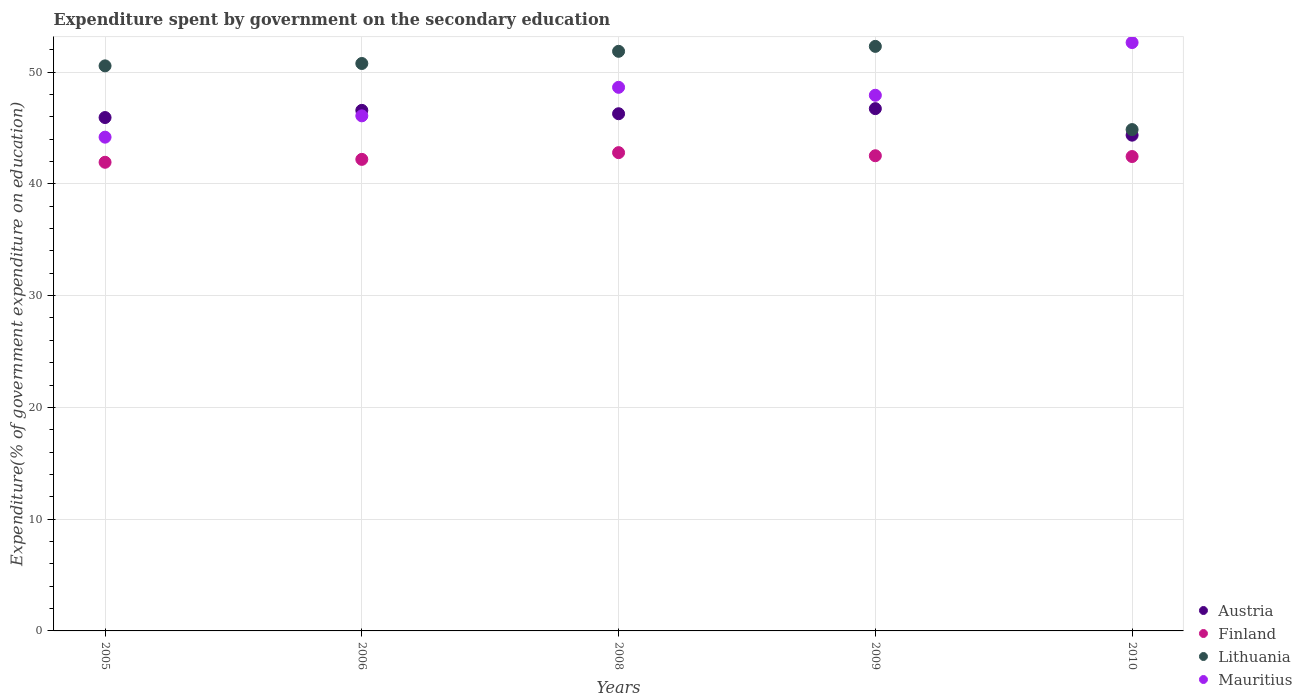What is the expenditure spent by government on the secondary education in Austria in 2005?
Your answer should be very brief. 45.94. Across all years, what is the maximum expenditure spent by government on the secondary education in Lithuania?
Keep it short and to the point. 52.3. Across all years, what is the minimum expenditure spent by government on the secondary education in Mauritius?
Ensure brevity in your answer.  44.18. In which year was the expenditure spent by government on the secondary education in Mauritius minimum?
Provide a succinct answer. 2005. What is the total expenditure spent by government on the secondary education in Mauritius in the graph?
Provide a succinct answer. 239.49. What is the difference between the expenditure spent by government on the secondary education in Finland in 2005 and that in 2006?
Provide a succinct answer. -0.26. What is the difference between the expenditure spent by government on the secondary education in Finland in 2006 and the expenditure spent by government on the secondary education in Austria in 2005?
Your answer should be compact. -3.74. What is the average expenditure spent by government on the secondary education in Finland per year?
Keep it short and to the point. 42.38. In the year 2008, what is the difference between the expenditure spent by government on the secondary education in Mauritius and expenditure spent by government on the secondary education in Lithuania?
Provide a succinct answer. -3.22. What is the ratio of the expenditure spent by government on the secondary education in Lithuania in 2008 to that in 2010?
Offer a very short reply. 1.16. What is the difference between the highest and the second highest expenditure spent by government on the secondary education in Lithuania?
Your response must be concise. 0.44. What is the difference between the highest and the lowest expenditure spent by government on the secondary education in Finland?
Make the answer very short. 0.86. Is it the case that in every year, the sum of the expenditure spent by government on the secondary education in Finland and expenditure spent by government on the secondary education in Mauritius  is greater than the sum of expenditure spent by government on the secondary education in Lithuania and expenditure spent by government on the secondary education in Austria?
Keep it short and to the point. No. Does the expenditure spent by government on the secondary education in Finland monotonically increase over the years?
Your answer should be very brief. No. How many years are there in the graph?
Your answer should be very brief. 5. Are the values on the major ticks of Y-axis written in scientific E-notation?
Your answer should be very brief. No. Where does the legend appear in the graph?
Your response must be concise. Bottom right. What is the title of the graph?
Make the answer very short. Expenditure spent by government on the secondary education. What is the label or title of the Y-axis?
Offer a terse response. Expenditure(% of government expenditure on education). What is the Expenditure(% of government expenditure on education) in Austria in 2005?
Give a very brief answer. 45.94. What is the Expenditure(% of government expenditure on education) in Finland in 2005?
Provide a short and direct response. 41.93. What is the Expenditure(% of government expenditure on education) of Lithuania in 2005?
Provide a succinct answer. 50.56. What is the Expenditure(% of government expenditure on education) of Mauritius in 2005?
Offer a terse response. 44.18. What is the Expenditure(% of government expenditure on education) of Austria in 2006?
Provide a succinct answer. 46.58. What is the Expenditure(% of government expenditure on education) of Finland in 2006?
Provide a short and direct response. 42.19. What is the Expenditure(% of government expenditure on education) of Lithuania in 2006?
Ensure brevity in your answer.  50.77. What is the Expenditure(% of government expenditure on education) in Mauritius in 2006?
Your answer should be very brief. 46.09. What is the Expenditure(% of government expenditure on education) of Austria in 2008?
Offer a very short reply. 46.28. What is the Expenditure(% of government expenditure on education) in Finland in 2008?
Provide a succinct answer. 42.8. What is the Expenditure(% of government expenditure on education) in Lithuania in 2008?
Your response must be concise. 51.86. What is the Expenditure(% of government expenditure on education) in Mauritius in 2008?
Provide a short and direct response. 48.64. What is the Expenditure(% of government expenditure on education) of Austria in 2009?
Make the answer very short. 46.73. What is the Expenditure(% of government expenditure on education) of Finland in 2009?
Offer a very short reply. 42.52. What is the Expenditure(% of government expenditure on education) in Lithuania in 2009?
Ensure brevity in your answer.  52.3. What is the Expenditure(% of government expenditure on education) in Mauritius in 2009?
Make the answer very short. 47.93. What is the Expenditure(% of government expenditure on education) of Austria in 2010?
Your answer should be compact. 44.36. What is the Expenditure(% of government expenditure on education) in Finland in 2010?
Your answer should be very brief. 42.45. What is the Expenditure(% of government expenditure on education) of Lithuania in 2010?
Give a very brief answer. 44.86. What is the Expenditure(% of government expenditure on education) of Mauritius in 2010?
Give a very brief answer. 52.65. Across all years, what is the maximum Expenditure(% of government expenditure on education) of Austria?
Provide a succinct answer. 46.73. Across all years, what is the maximum Expenditure(% of government expenditure on education) of Finland?
Your answer should be very brief. 42.8. Across all years, what is the maximum Expenditure(% of government expenditure on education) of Lithuania?
Your answer should be very brief. 52.3. Across all years, what is the maximum Expenditure(% of government expenditure on education) in Mauritius?
Provide a succinct answer. 52.65. Across all years, what is the minimum Expenditure(% of government expenditure on education) in Austria?
Offer a terse response. 44.36. Across all years, what is the minimum Expenditure(% of government expenditure on education) in Finland?
Your answer should be very brief. 41.93. Across all years, what is the minimum Expenditure(% of government expenditure on education) of Lithuania?
Provide a succinct answer. 44.86. Across all years, what is the minimum Expenditure(% of government expenditure on education) of Mauritius?
Offer a terse response. 44.18. What is the total Expenditure(% of government expenditure on education) in Austria in the graph?
Offer a very short reply. 229.89. What is the total Expenditure(% of government expenditure on education) of Finland in the graph?
Ensure brevity in your answer.  211.89. What is the total Expenditure(% of government expenditure on education) in Lithuania in the graph?
Provide a succinct answer. 250.36. What is the total Expenditure(% of government expenditure on education) in Mauritius in the graph?
Your response must be concise. 239.49. What is the difference between the Expenditure(% of government expenditure on education) in Austria in 2005 and that in 2006?
Offer a terse response. -0.64. What is the difference between the Expenditure(% of government expenditure on education) of Finland in 2005 and that in 2006?
Give a very brief answer. -0.26. What is the difference between the Expenditure(% of government expenditure on education) of Lithuania in 2005 and that in 2006?
Give a very brief answer. -0.21. What is the difference between the Expenditure(% of government expenditure on education) in Mauritius in 2005 and that in 2006?
Provide a succinct answer. -1.91. What is the difference between the Expenditure(% of government expenditure on education) in Austria in 2005 and that in 2008?
Your response must be concise. -0.34. What is the difference between the Expenditure(% of government expenditure on education) of Finland in 2005 and that in 2008?
Your answer should be very brief. -0.86. What is the difference between the Expenditure(% of government expenditure on education) of Lithuania in 2005 and that in 2008?
Keep it short and to the point. -1.3. What is the difference between the Expenditure(% of government expenditure on education) of Mauritius in 2005 and that in 2008?
Provide a succinct answer. -4.46. What is the difference between the Expenditure(% of government expenditure on education) in Austria in 2005 and that in 2009?
Provide a succinct answer. -0.8. What is the difference between the Expenditure(% of government expenditure on education) in Finland in 2005 and that in 2009?
Make the answer very short. -0.58. What is the difference between the Expenditure(% of government expenditure on education) of Lithuania in 2005 and that in 2009?
Provide a short and direct response. -1.74. What is the difference between the Expenditure(% of government expenditure on education) in Mauritius in 2005 and that in 2009?
Offer a terse response. -3.75. What is the difference between the Expenditure(% of government expenditure on education) of Austria in 2005 and that in 2010?
Your response must be concise. 1.58. What is the difference between the Expenditure(% of government expenditure on education) of Finland in 2005 and that in 2010?
Give a very brief answer. -0.51. What is the difference between the Expenditure(% of government expenditure on education) of Lithuania in 2005 and that in 2010?
Offer a terse response. 5.7. What is the difference between the Expenditure(% of government expenditure on education) of Mauritius in 2005 and that in 2010?
Ensure brevity in your answer.  -8.46. What is the difference between the Expenditure(% of government expenditure on education) of Austria in 2006 and that in 2008?
Give a very brief answer. 0.3. What is the difference between the Expenditure(% of government expenditure on education) in Finland in 2006 and that in 2008?
Make the answer very short. -0.6. What is the difference between the Expenditure(% of government expenditure on education) in Lithuania in 2006 and that in 2008?
Keep it short and to the point. -1.09. What is the difference between the Expenditure(% of government expenditure on education) of Mauritius in 2006 and that in 2008?
Give a very brief answer. -2.55. What is the difference between the Expenditure(% of government expenditure on education) of Austria in 2006 and that in 2009?
Provide a succinct answer. -0.15. What is the difference between the Expenditure(% of government expenditure on education) in Finland in 2006 and that in 2009?
Your response must be concise. -0.32. What is the difference between the Expenditure(% of government expenditure on education) in Lithuania in 2006 and that in 2009?
Keep it short and to the point. -1.53. What is the difference between the Expenditure(% of government expenditure on education) of Mauritius in 2006 and that in 2009?
Provide a succinct answer. -1.84. What is the difference between the Expenditure(% of government expenditure on education) in Austria in 2006 and that in 2010?
Your response must be concise. 2.22. What is the difference between the Expenditure(% of government expenditure on education) of Finland in 2006 and that in 2010?
Ensure brevity in your answer.  -0.25. What is the difference between the Expenditure(% of government expenditure on education) of Lithuania in 2006 and that in 2010?
Your response must be concise. 5.91. What is the difference between the Expenditure(% of government expenditure on education) of Mauritius in 2006 and that in 2010?
Keep it short and to the point. -6.56. What is the difference between the Expenditure(% of government expenditure on education) in Austria in 2008 and that in 2009?
Offer a very short reply. -0.46. What is the difference between the Expenditure(% of government expenditure on education) of Finland in 2008 and that in 2009?
Provide a succinct answer. 0.28. What is the difference between the Expenditure(% of government expenditure on education) of Lithuania in 2008 and that in 2009?
Ensure brevity in your answer.  -0.44. What is the difference between the Expenditure(% of government expenditure on education) of Mauritius in 2008 and that in 2009?
Your answer should be compact. 0.71. What is the difference between the Expenditure(% of government expenditure on education) of Austria in 2008 and that in 2010?
Make the answer very short. 1.92. What is the difference between the Expenditure(% of government expenditure on education) in Finland in 2008 and that in 2010?
Ensure brevity in your answer.  0.35. What is the difference between the Expenditure(% of government expenditure on education) in Lithuania in 2008 and that in 2010?
Offer a terse response. 7. What is the difference between the Expenditure(% of government expenditure on education) of Mauritius in 2008 and that in 2010?
Keep it short and to the point. -4.01. What is the difference between the Expenditure(% of government expenditure on education) of Austria in 2009 and that in 2010?
Your answer should be very brief. 2.37. What is the difference between the Expenditure(% of government expenditure on education) of Finland in 2009 and that in 2010?
Offer a very short reply. 0.07. What is the difference between the Expenditure(% of government expenditure on education) in Lithuania in 2009 and that in 2010?
Your answer should be very brief. 7.45. What is the difference between the Expenditure(% of government expenditure on education) in Mauritius in 2009 and that in 2010?
Provide a succinct answer. -4.72. What is the difference between the Expenditure(% of government expenditure on education) in Austria in 2005 and the Expenditure(% of government expenditure on education) in Finland in 2006?
Provide a short and direct response. 3.74. What is the difference between the Expenditure(% of government expenditure on education) in Austria in 2005 and the Expenditure(% of government expenditure on education) in Lithuania in 2006?
Provide a succinct answer. -4.84. What is the difference between the Expenditure(% of government expenditure on education) of Austria in 2005 and the Expenditure(% of government expenditure on education) of Mauritius in 2006?
Provide a short and direct response. -0.15. What is the difference between the Expenditure(% of government expenditure on education) of Finland in 2005 and the Expenditure(% of government expenditure on education) of Lithuania in 2006?
Provide a succinct answer. -8.84. What is the difference between the Expenditure(% of government expenditure on education) in Finland in 2005 and the Expenditure(% of government expenditure on education) in Mauritius in 2006?
Keep it short and to the point. -4.15. What is the difference between the Expenditure(% of government expenditure on education) of Lithuania in 2005 and the Expenditure(% of government expenditure on education) of Mauritius in 2006?
Provide a succinct answer. 4.47. What is the difference between the Expenditure(% of government expenditure on education) in Austria in 2005 and the Expenditure(% of government expenditure on education) in Finland in 2008?
Provide a short and direct response. 3.14. What is the difference between the Expenditure(% of government expenditure on education) in Austria in 2005 and the Expenditure(% of government expenditure on education) in Lithuania in 2008?
Offer a terse response. -5.93. What is the difference between the Expenditure(% of government expenditure on education) of Austria in 2005 and the Expenditure(% of government expenditure on education) of Mauritius in 2008?
Provide a succinct answer. -2.7. What is the difference between the Expenditure(% of government expenditure on education) in Finland in 2005 and the Expenditure(% of government expenditure on education) in Lithuania in 2008?
Your response must be concise. -9.93. What is the difference between the Expenditure(% of government expenditure on education) of Finland in 2005 and the Expenditure(% of government expenditure on education) of Mauritius in 2008?
Your answer should be compact. -6.71. What is the difference between the Expenditure(% of government expenditure on education) of Lithuania in 2005 and the Expenditure(% of government expenditure on education) of Mauritius in 2008?
Keep it short and to the point. 1.92. What is the difference between the Expenditure(% of government expenditure on education) of Austria in 2005 and the Expenditure(% of government expenditure on education) of Finland in 2009?
Make the answer very short. 3.42. What is the difference between the Expenditure(% of government expenditure on education) of Austria in 2005 and the Expenditure(% of government expenditure on education) of Lithuania in 2009?
Offer a very short reply. -6.37. What is the difference between the Expenditure(% of government expenditure on education) in Austria in 2005 and the Expenditure(% of government expenditure on education) in Mauritius in 2009?
Offer a terse response. -1.99. What is the difference between the Expenditure(% of government expenditure on education) in Finland in 2005 and the Expenditure(% of government expenditure on education) in Lithuania in 2009?
Your response must be concise. -10.37. What is the difference between the Expenditure(% of government expenditure on education) in Finland in 2005 and the Expenditure(% of government expenditure on education) in Mauritius in 2009?
Keep it short and to the point. -6. What is the difference between the Expenditure(% of government expenditure on education) in Lithuania in 2005 and the Expenditure(% of government expenditure on education) in Mauritius in 2009?
Give a very brief answer. 2.63. What is the difference between the Expenditure(% of government expenditure on education) in Austria in 2005 and the Expenditure(% of government expenditure on education) in Finland in 2010?
Keep it short and to the point. 3.49. What is the difference between the Expenditure(% of government expenditure on education) in Austria in 2005 and the Expenditure(% of government expenditure on education) in Lithuania in 2010?
Offer a terse response. 1.08. What is the difference between the Expenditure(% of government expenditure on education) in Austria in 2005 and the Expenditure(% of government expenditure on education) in Mauritius in 2010?
Offer a terse response. -6.71. What is the difference between the Expenditure(% of government expenditure on education) of Finland in 2005 and the Expenditure(% of government expenditure on education) of Lithuania in 2010?
Your answer should be compact. -2.92. What is the difference between the Expenditure(% of government expenditure on education) of Finland in 2005 and the Expenditure(% of government expenditure on education) of Mauritius in 2010?
Ensure brevity in your answer.  -10.71. What is the difference between the Expenditure(% of government expenditure on education) in Lithuania in 2005 and the Expenditure(% of government expenditure on education) in Mauritius in 2010?
Keep it short and to the point. -2.09. What is the difference between the Expenditure(% of government expenditure on education) in Austria in 2006 and the Expenditure(% of government expenditure on education) in Finland in 2008?
Offer a terse response. 3.78. What is the difference between the Expenditure(% of government expenditure on education) in Austria in 2006 and the Expenditure(% of government expenditure on education) in Lithuania in 2008?
Ensure brevity in your answer.  -5.28. What is the difference between the Expenditure(% of government expenditure on education) in Austria in 2006 and the Expenditure(% of government expenditure on education) in Mauritius in 2008?
Your answer should be compact. -2.06. What is the difference between the Expenditure(% of government expenditure on education) in Finland in 2006 and the Expenditure(% of government expenditure on education) in Lithuania in 2008?
Ensure brevity in your answer.  -9.67. What is the difference between the Expenditure(% of government expenditure on education) of Finland in 2006 and the Expenditure(% of government expenditure on education) of Mauritius in 2008?
Keep it short and to the point. -6.45. What is the difference between the Expenditure(% of government expenditure on education) in Lithuania in 2006 and the Expenditure(% of government expenditure on education) in Mauritius in 2008?
Keep it short and to the point. 2.13. What is the difference between the Expenditure(% of government expenditure on education) in Austria in 2006 and the Expenditure(% of government expenditure on education) in Finland in 2009?
Keep it short and to the point. 4.06. What is the difference between the Expenditure(% of government expenditure on education) in Austria in 2006 and the Expenditure(% of government expenditure on education) in Lithuania in 2009?
Your answer should be compact. -5.73. What is the difference between the Expenditure(% of government expenditure on education) in Austria in 2006 and the Expenditure(% of government expenditure on education) in Mauritius in 2009?
Ensure brevity in your answer.  -1.35. What is the difference between the Expenditure(% of government expenditure on education) of Finland in 2006 and the Expenditure(% of government expenditure on education) of Lithuania in 2009?
Make the answer very short. -10.11. What is the difference between the Expenditure(% of government expenditure on education) in Finland in 2006 and the Expenditure(% of government expenditure on education) in Mauritius in 2009?
Keep it short and to the point. -5.74. What is the difference between the Expenditure(% of government expenditure on education) of Lithuania in 2006 and the Expenditure(% of government expenditure on education) of Mauritius in 2009?
Offer a very short reply. 2.84. What is the difference between the Expenditure(% of government expenditure on education) in Austria in 2006 and the Expenditure(% of government expenditure on education) in Finland in 2010?
Your answer should be very brief. 4.13. What is the difference between the Expenditure(% of government expenditure on education) of Austria in 2006 and the Expenditure(% of government expenditure on education) of Lithuania in 2010?
Keep it short and to the point. 1.72. What is the difference between the Expenditure(% of government expenditure on education) in Austria in 2006 and the Expenditure(% of government expenditure on education) in Mauritius in 2010?
Your answer should be very brief. -6.07. What is the difference between the Expenditure(% of government expenditure on education) of Finland in 2006 and the Expenditure(% of government expenditure on education) of Lithuania in 2010?
Give a very brief answer. -2.67. What is the difference between the Expenditure(% of government expenditure on education) in Finland in 2006 and the Expenditure(% of government expenditure on education) in Mauritius in 2010?
Give a very brief answer. -10.45. What is the difference between the Expenditure(% of government expenditure on education) in Lithuania in 2006 and the Expenditure(% of government expenditure on education) in Mauritius in 2010?
Keep it short and to the point. -1.87. What is the difference between the Expenditure(% of government expenditure on education) in Austria in 2008 and the Expenditure(% of government expenditure on education) in Finland in 2009?
Offer a very short reply. 3.76. What is the difference between the Expenditure(% of government expenditure on education) in Austria in 2008 and the Expenditure(% of government expenditure on education) in Lithuania in 2009?
Keep it short and to the point. -6.03. What is the difference between the Expenditure(% of government expenditure on education) of Austria in 2008 and the Expenditure(% of government expenditure on education) of Mauritius in 2009?
Offer a terse response. -1.65. What is the difference between the Expenditure(% of government expenditure on education) of Finland in 2008 and the Expenditure(% of government expenditure on education) of Lithuania in 2009?
Keep it short and to the point. -9.51. What is the difference between the Expenditure(% of government expenditure on education) of Finland in 2008 and the Expenditure(% of government expenditure on education) of Mauritius in 2009?
Keep it short and to the point. -5.13. What is the difference between the Expenditure(% of government expenditure on education) of Lithuania in 2008 and the Expenditure(% of government expenditure on education) of Mauritius in 2009?
Offer a terse response. 3.93. What is the difference between the Expenditure(% of government expenditure on education) in Austria in 2008 and the Expenditure(% of government expenditure on education) in Finland in 2010?
Provide a short and direct response. 3.83. What is the difference between the Expenditure(% of government expenditure on education) of Austria in 2008 and the Expenditure(% of government expenditure on education) of Lithuania in 2010?
Provide a short and direct response. 1.42. What is the difference between the Expenditure(% of government expenditure on education) of Austria in 2008 and the Expenditure(% of government expenditure on education) of Mauritius in 2010?
Provide a succinct answer. -6.37. What is the difference between the Expenditure(% of government expenditure on education) of Finland in 2008 and the Expenditure(% of government expenditure on education) of Lithuania in 2010?
Your response must be concise. -2.06. What is the difference between the Expenditure(% of government expenditure on education) of Finland in 2008 and the Expenditure(% of government expenditure on education) of Mauritius in 2010?
Make the answer very short. -9.85. What is the difference between the Expenditure(% of government expenditure on education) of Lithuania in 2008 and the Expenditure(% of government expenditure on education) of Mauritius in 2010?
Offer a very short reply. -0.78. What is the difference between the Expenditure(% of government expenditure on education) of Austria in 2009 and the Expenditure(% of government expenditure on education) of Finland in 2010?
Offer a terse response. 4.29. What is the difference between the Expenditure(% of government expenditure on education) in Austria in 2009 and the Expenditure(% of government expenditure on education) in Lithuania in 2010?
Keep it short and to the point. 1.87. What is the difference between the Expenditure(% of government expenditure on education) in Austria in 2009 and the Expenditure(% of government expenditure on education) in Mauritius in 2010?
Offer a terse response. -5.91. What is the difference between the Expenditure(% of government expenditure on education) of Finland in 2009 and the Expenditure(% of government expenditure on education) of Lithuania in 2010?
Offer a terse response. -2.34. What is the difference between the Expenditure(% of government expenditure on education) in Finland in 2009 and the Expenditure(% of government expenditure on education) in Mauritius in 2010?
Your answer should be very brief. -10.13. What is the difference between the Expenditure(% of government expenditure on education) of Lithuania in 2009 and the Expenditure(% of government expenditure on education) of Mauritius in 2010?
Your answer should be compact. -0.34. What is the average Expenditure(% of government expenditure on education) of Austria per year?
Ensure brevity in your answer.  45.98. What is the average Expenditure(% of government expenditure on education) in Finland per year?
Offer a very short reply. 42.38. What is the average Expenditure(% of government expenditure on education) of Lithuania per year?
Provide a succinct answer. 50.07. What is the average Expenditure(% of government expenditure on education) of Mauritius per year?
Make the answer very short. 47.9. In the year 2005, what is the difference between the Expenditure(% of government expenditure on education) of Austria and Expenditure(% of government expenditure on education) of Finland?
Provide a short and direct response. 4. In the year 2005, what is the difference between the Expenditure(% of government expenditure on education) of Austria and Expenditure(% of government expenditure on education) of Lithuania?
Your response must be concise. -4.62. In the year 2005, what is the difference between the Expenditure(% of government expenditure on education) in Austria and Expenditure(% of government expenditure on education) in Mauritius?
Make the answer very short. 1.76. In the year 2005, what is the difference between the Expenditure(% of government expenditure on education) in Finland and Expenditure(% of government expenditure on education) in Lithuania?
Give a very brief answer. -8.63. In the year 2005, what is the difference between the Expenditure(% of government expenditure on education) of Finland and Expenditure(% of government expenditure on education) of Mauritius?
Your answer should be compact. -2.25. In the year 2005, what is the difference between the Expenditure(% of government expenditure on education) of Lithuania and Expenditure(% of government expenditure on education) of Mauritius?
Keep it short and to the point. 6.38. In the year 2006, what is the difference between the Expenditure(% of government expenditure on education) of Austria and Expenditure(% of government expenditure on education) of Finland?
Offer a terse response. 4.39. In the year 2006, what is the difference between the Expenditure(% of government expenditure on education) of Austria and Expenditure(% of government expenditure on education) of Lithuania?
Offer a terse response. -4.19. In the year 2006, what is the difference between the Expenditure(% of government expenditure on education) in Austria and Expenditure(% of government expenditure on education) in Mauritius?
Ensure brevity in your answer.  0.49. In the year 2006, what is the difference between the Expenditure(% of government expenditure on education) of Finland and Expenditure(% of government expenditure on education) of Lithuania?
Your answer should be very brief. -8.58. In the year 2006, what is the difference between the Expenditure(% of government expenditure on education) in Finland and Expenditure(% of government expenditure on education) in Mauritius?
Keep it short and to the point. -3.89. In the year 2006, what is the difference between the Expenditure(% of government expenditure on education) of Lithuania and Expenditure(% of government expenditure on education) of Mauritius?
Your answer should be very brief. 4.68. In the year 2008, what is the difference between the Expenditure(% of government expenditure on education) in Austria and Expenditure(% of government expenditure on education) in Finland?
Give a very brief answer. 3.48. In the year 2008, what is the difference between the Expenditure(% of government expenditure on education) of Austria and Expenditure(% of government expenditure on education) of Lithuania?
Make the answer very short. -5.59. In the year 2008, what is the difference between the Expenditure(% of government expenditure on education) in Austria and Expenditure(% of government expenditure on education) in Mauritius?
Your answer should be very brief. -2.36. In the year 2008, what is the difference between the Expenditure(% of government expenditure on education) in Finland and Expenditure(% of government expenditure on education) in Lithuania?
Provide a succinct answer. -9.07. In the year 2008, what is the difference between the Expenditure(% of government expenditure on education) of Finland and Expenditure(% of government expenditure on education) of Mauritius?
Make the answer very short. -5.84. In the year 2008, what is the difference between the Expenditure(% of government expenditure on education) of Lithuania and Expenditure(% of government expenditure on education) of Mauritius?
Provide a succinct answer. 3.22. In the year 2009, what is the difference between the Expenditure(% of government expenditure on education) of Austria and Expenditure(% of government expenditure on education) of Finland?
Offer a terse response. 4.22. In the year 2009, what is the difference between the Expenditure(% of government expenditure on education) in Austria and Expenditure(% of government expenditure on education) in Lithuania?
Make the answer very short. -5.57. In the year 2009, what is the difference between the Expenditure(% of government expenditure on education) in Austria and Expenditure(% of government expenditure on education) in Mauritius?
Your response must be concise. -1.2. In the year 2009, what is the difference between the Expenditure(% of government expenditure on education) of Finland and Expenditure(% of government expenditure on education) of Lithuania?
Give a very brief answer. -9.79. In the year 2009, what is the difference between the Expenditure(% of government expenditure on education) in Finland and Expenditure(% of government expenditure on education) in Mauritius?
Provide a succinct answer. -5.41. In the year 2009, what is the difference between the Expenditure(% of government expenditure on education) of Lithuania and Expenditure(% of government expenditure on education) of Mauritius?
Your response must be concise. 4.37. In the year 2010, what is the difference between the Expenditure(% of government expenditure on education) of Austria and Expenditure(% of government expenditure on education) of Finland?
Offer a very short reply. 1.91. In the year 2010, what is the difference between the Expenditure(% of government expenditure on education) in Austria and Expenditure(% of government expenditure on education) in Lithuania?
Your answer should be compact. -0.5. In the year 2010, what is the difference between the Expenditure(% of government expenditure on education) in Austria and Expenditure(% of government expenditure on education) in Mauritius?
Your response must be concise. -8.29. In the year 2010, what is the difference between the Expenditure(% of government expenditure on education) in Finland and Expenditure(% of government expenditure on education) in Lithuania?
Give a very brief answer. -2.41. In the year 2010, what is the difference between the Expenditure(% of government expenditure on education) of Finland and Expenditure(% of government expenditure on education) of Mauritius?
Your answer should be very brief. -10.2. In the year 2010, what is the difference between the Expenditure(% of government expenditure on education) of Lithuania and Expenditure(% of government expenditure on education) of Mauritius?
Give a very brief answer. -7.79. What is the ratio of the Expenditure(% of government expenditure on education) in Austria in 2005 to that in 2006?
Your response must be concise. 0.99. What is the ratio of the Expenditure(% of government expenditure on education) in Mauritius in 2005 to that in 2006?
Provide a succinct answer. 0.96. What is the ratio of the Expenditure(% of government expenditure on education) in Austria in 2005 to that in 2008?
Your answer should be compact. 0.99. What is the ratio of the Expenditure(% of government expenditure on education) in Finland in 2005 to that in 2008?
Offer a very short reply. 0.98. What is the ratio of the Expenditure(% of government expenditure on education) in Lithuania in 2005 to that in 2008?
Offer a terse response. 0.97. What is the ratio of the Expenditure(% of government expenditure on education) of Mauritius in 2005 to that in 2008?
Provide a succinct answer. 0.91. What is the ratio of the Expenditure(% of government expenditure on education) in Austria in 2005 to that in 2009?
Your answer should be very brief. 0.98. What is the ratio of the Expenditure(% of government expenditure on education) in Finland in 2005 to that in 2009?
Your answer should be compact. 0.99. What is the ratio of the Expenditure(% of government expenditure on education) of Lithuania in 2005 to that in 2009?
Your answer should be very brief. 0.97. What is the ratio of the Expenditure(% of government expenditure on education) of Mauritius in 2005 to that in 2009?
Provide a succinct answer. 0.92. What is the ratio of the Expenditure(% of government expenditure on education) in Austria in 2005 to that in 2010?
Offer a very short reply. 1.04. What is the ratio of the Expenditure(% of government expenditure on education) of Finland in 2005 to that in 2010?
Ensure brevity in your answer.  0.99. What is the ratio of the Expenditure(% of government expenditure on education) in Lithuania in 2005 to that in 2010?
Provide a short and direct response. 1.13. What is the ratio of the Expenditure(% of government expenditure on education) of Mauritius in 2005 to that in 2010?
Provide a short and direct response. 0.84. What is the ratio of the Expenditure(% of government expenditure on education) of Finland in 2006 to that in 2008?
Keep it short and to the point. 0.99. What is the ratio of the Expenditure(% of government expenditure on education) of Lithuania in 2006 to that in 2008?
Keep it short and to the point. 0.98. What is the ratio of the Expenditure(% of government expenditure on education) in Mauritius in 2006 to that in 2008?
Your answer should be very brief. 0.95. What is the ratio of the Expenditure(% of government expenditure on education) in Finland in 2006 to that in 2009?
Provide a short and direct response. 0.99. What is the ratio of the Expenditure(% of government expenditure on education) of Lithuania in 2006 to that in 2009?
Offer a very short reply. 0.97. What is the ratio of the Expenditure(% of government expenditure on education) of Mauritius in 2006 to that in 2009?
Ensure brevity in your answer.  0.96. What is the ratio of the Expenditure(% of government expenditure on education) in Lithuania in 2006 to that in 2010?
Ensure brevity in your answer.  1.13. What is the ratio of the Expenditure(% of government expenditure on education) of Mauritius in 2006 to that in 2010?
Give a very brief answer. 0.88. What is the ratio of the Expenditure(% of government expenditure on education) of Austria in 2008 to that in 2009?
Offer a very short reply. 0.99. What is the ratio of the Expenditure(% of government expenditure on education) of Finland in 2008 to that in 2009?
Ensure brevity in your answer.  1.01. What is the ratio of the Expenditure(% of government expenditure on education) in Mauritius in 2008 to that in 2009?
Ensure brevity in your answer.  1.01. What is the ratio of the Expenditure(% of government expenditure on education) in Austria in 2008 to that in 2010?
Your response must be concise. 1.04. What is the ratio of the Expenditure(% of government expenditure on education) in Finland in 2008 to that in 2010?
Offer a terse response. 1.01. What is the ratio of the Expenditure(% of government expenditure on education) in Lithuania in 2008 to that in 2010?
Ensure brevity in your answer.  1.16. What is the ratio of the Expenditure(% of government expenditure on education) in Mauritius in 2008 to that in 2010?
Provide a succinct answer. 0.92. What is the ratio of the Expenditure(% of government expenditure on education) in Austria in 2009 to that in 2010?
Keep it short and to the point. 1.05. What is the ratio of the Expenditure(% of government expenditure on education) in Finland in 2009 to that in 2010?
Offer a very short reply. 1. What is the ratio of the Expenditure(% of government expenditure on education) in Lithuania in 2009 to that in 2010?
Offer a very short reply. 1.17. What is the ratio of the Expenditure(% of government expenditure on education) in Mauritius in 2009 to that in 2010?
Offer a terse response. 0.91. What is the difference between the highest and the second highest Expenditure(% of government expenditure on education) in Austria?
Your answer should be very brief. 0.15. What is the difference between the highest and the second highest Expenditure(% of government expenditure on education) of Finland?
Make the answer very short. 0.28. What is the difference between the highest and the second highest Expenditure(% of government expenditure on education) in Lithuania?
Give a very brief answer. 0.44. What is the difference between the highest and the second highest Expenditure(% of government expenditure on education) in Mauritius?
Ensure brevity in your answer.  4.01. What is the difference between the highest and the lowest Expenditure(% of government expenditure on education) in Austria?
Offer a very short reply. 2.37. What is the difference between the highest and the lowest Expenditure(% of government expenditure on education) in Finland?
Provide a succinct answer. 0.86. What is the difference between the highest and the lowest Expenditure(% of government expenditure on education) of Lithuania?
Provide a short and direct response. 7.45. What is the difference between the highest and the lowest Expenditure(% of government expenditure on education) of Mauritius?
Make the answer very short. 8.46. 